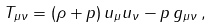<formula> <loc_0><loc_0><loc_500><loc_500>T _ { \mu \nu } = ( \rho + p ) \, u _ { \mu } u _ { \nu } - p \, g _ { \mu \nu } \, ,</formula> 